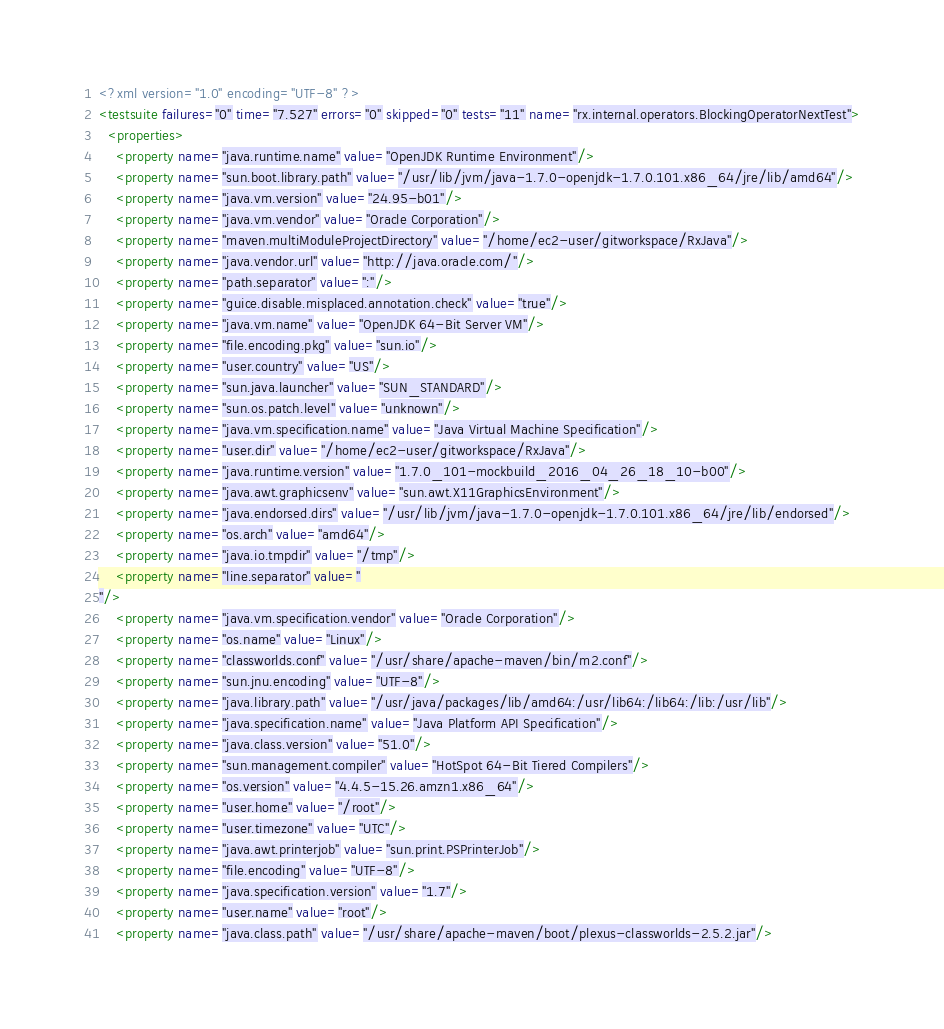<code> <loc_0><loc_0><loc_500><loc_500><_XML_><?xml version="1.0" encoding="UTF-8" ?>
<testsuite failures="0" time="7.527" errors="0" skipped="0" tests="11" name="rx.internal.operators.BlockingOperatorNextTest">
  <properties>
    <property name="java.runtime.name" value="OpenJDK Runtime Environment"/>
    <property name="sun.boot.library.path" value="/usr/lib/jvm/java-1.7.0-openjdk-1.7.0.101.x86_64/jre/lib/amd64"/>
    <property name="java.vm.version" value="24.95-b01"/>
    <property name="java.vm.vendor" value="Oracle Corporation"/>
    <property name="maven.multiModuleProjectDirectory" value="/home/ec2-user/gitworkspace/RxJava"/>
    <property name="java.vendor.url" value="http://java.oracle.com/"/>
    <property name="path.separator" value=":"/>
    <property name="guice.disable.misplaced.annotation.check" value="true"/>
    <property name="java.vm.name" value="OpenJDK 64-Bit Server VM"/>
    <property name="file.encoding.pkg" value="sun.io"/>
    <property name="user.country" value="US"/>
    <property name="sun.java.launcher" value="SUN_STANDARD"/>
    <property name="sun.os.patch.level" value="unknown"/>
    <property name="java.vm.specification.name" value="Java Virtual Machine Specification"/>
    <property name="user.dir" value="/home/ec2-user/gitworkspace/RxJava"/>
    <property name="java.runtime.version" value="1.7.0_101-mockbuild_2016_04_26_18_10-b00"/>
    <property name="java.awt.graphicsenv" value="sun.awt.X11GraphicsEnvironment"/>
    <property name="java.endorsed.dirs" value="/usr/lib/jvm/java-1.7.0-openjdk-1.7.0.101.x86_64/jre/lib/endorsed"/>
    <property name="os.arch" value="amd64"/>
    <property name="java.io.tmpdir" value="/tmp"/>
    <property name="line.separator" value="
"/>
    <property name="java.vm.specification.vendor" value="Oracle Corporation"/>
    <property name="os.name" value="Linux"/>
    <property name="classworlds.conf" value="/usr/share/apache-maven/bin/m2.conf"/>
    <property name="sun.jnu.encoding" value="UTF-8"/>
    <property name="java.library.path" value="/usr/java/packages/lib/amd64:/usr/lib64:/lib64:/lib:/usr/lib"/>
    <property name="java.specification.name" value="Java Platform API Specification"/>
    <property name="java.class.version" value="51.0"/>
    <property name="sun.management.compiler" value="HotSpot 64-Bit Tiered Compilers"/>
    <property name="os.version" value="4.4.5-15.26.amzn1.x86_64"/>
    <property name="user.home" value="/root"/>
    <property name="user.timezone" value="UTC"/>
    <property name="java.awt.printerjob" value="sun.print.PSPrinterJob"/>
    <property name="file.encoding" value="UTF-8"/>
    <property name="java.specification.version" value="1.7"/>
    <property name="user.name" value="root"/>
    <property name="java.class.path" value="/usr/share/apache-maven/boot/plexus-classworlds-2.5.2.jar"/></code> 